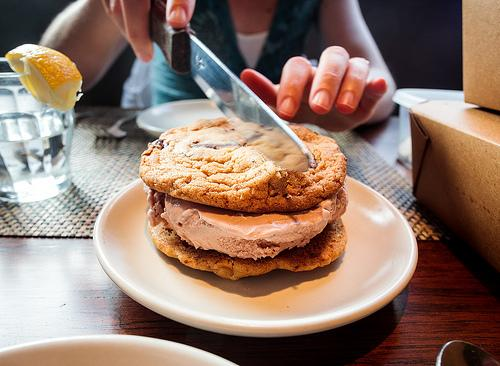Describe the texture contrast of the main dish in the image. The ice cream sandwich juxtaposes the soft, creamy chocolate ice cream with the crunchy, chocolate-chip-studded cookie exterior. Describe the image from the perspective of someone who is about to enjoy the dessert. With eager anticipation, I watch the woman expertly slice the ice cream sandwich, the chocolate chips in the cookie glistening from the light, as I sip on my glass of water garnished with a lemon slice. Summarize the key elements of the image in a brief sentence. A woman is cutting an ice cream cookie sandwich served on a white plate, with a glass of water with a lemon slice nearby. Write a sentence emphasizing the color palette in the image. The image boasts a blend of creamy whites, rich browns, and zesty lemon-yellows, with hints of silver from utensils. Mention the drink featured in the image and its garnish. A glass of water has a yellow lime slice perched on top, adding color and zing to the drink. Write a sentence highlighting the arrangement of elements in the image. The image presents a neatly laid out scene, with an ice cream sandwich in the center, surrounded by reflective silver cutlery and a clear glass of water with a lemon wedge. Mention the main dish in the image along with its main components. The main dish is a cookie ice cream sandwich with chocolate ice cream between two chocolate chip cookies. Provide a poetic description of the image. A delectable ice cream sandwich rests upon a pristine, white plate as a woman gently slices it, while a refreshing lemon-kissed glass of water awaits to quench her thirst. Write a sentence focusing on the utensils, cutlery, and props in the image. A silver butter knife with a wooden handle, a silver-plated fork, and a stainless steel spoon lay scattered around the white plate and clear glass. Describe the woman's appearance and how she is involved in the image. A woman wearing a white undershirt and nicely manicured nails deftly cuts an ice cream cookie sandwich using a long silver knife. 